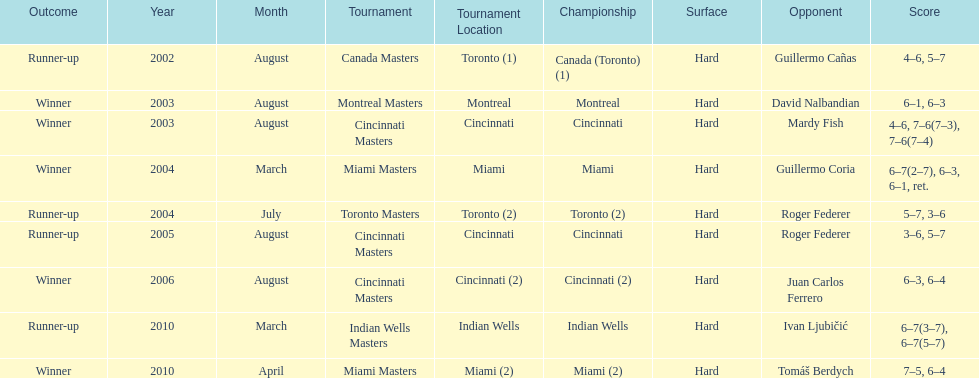How many times has he been runner-up? 4. 